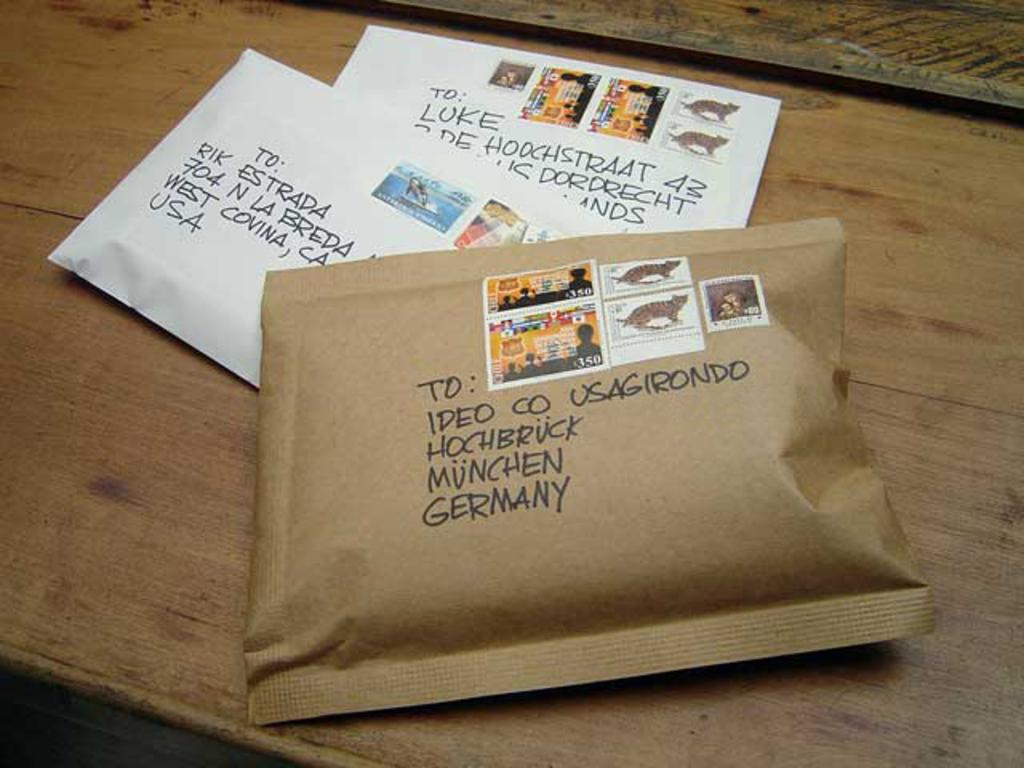<image>
Share a concise interpretation of the image provided. A package is addressed to Germany and has several stamps on it. 